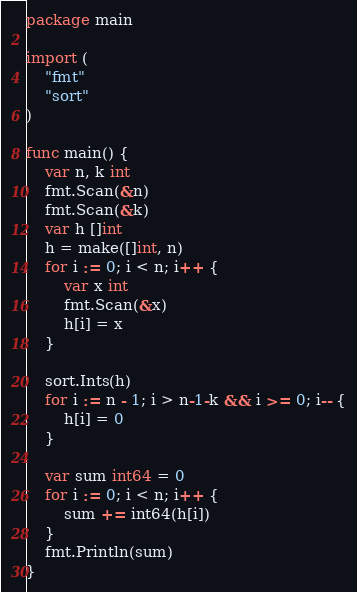Convert code to text. <code><loc_0><loc_0><loc_500><loc_500><_Go_>package main

import (
	"fmt"
	"sort"
)

func main() {
	var n, k int
	fmt.Scan(&n)
	fmt.Scan(&k)
	var h []int
	h = make([]int, n)
	for i := 0; i < n; i++ {
		var x int
		fmt.Scan(&x)
		h[i] = x
	}

	sort.Ints(h)
	for i := n - 1; i > n-1-k && i >= 0; i-- {
		h[i] = 0
	}

	var sum int64 = 0
	for i := 0; i < n; i++ {
		sum += int64(h[i])
	}
	fmt.Println(sum)
}
</code> 